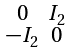<formula> <loc_0><loc_0><loc_500><loc_500>\begin{smallmatrix} 0 & I _ { 2 } \\ - I _ { 2 } & 0 \end{smallmatrix}</formula> 